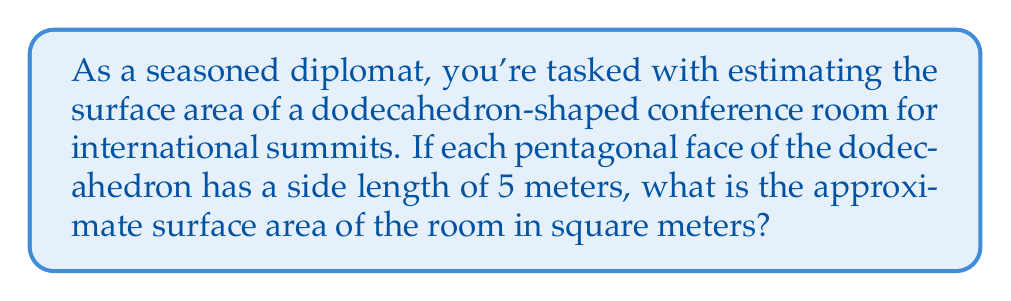Show me your answer to this math problem. Let's approach this step-by-step:

1) A dodecahedron has 12 pentagonal faces.

2) To find the surface area, we need to calculate the area of one pentagonal face and multiply it by 12.

3) The area of a regular pentagon with side length $s$ is given by:

   $$A = \frac{1}{4}\sqrt{25+10\sqrt{5}}s^2$$

4) In this case, $s = 5$ meters. Let's substitute this into the formula:

   $$A = \frac{1}{4}\sqrt{25+10\sqrt{5}}(5^2)$$

5) Simplify:
   $$A = \frac{25}{4}\sqrt{25+10\sqrt{5}}$$

6) Calculate this value (you may use a calculator):
   $$A \approx 43.01 \text{ m}^2$$

7) Since there are 12 faces, multiply this result by 12:

   $$\text{Total Surface Area} = 12 \times 43.01 \approx 516.12 \text{ m}^2$$

8) Rounding to the nearest whole number for a reasonable estimate:

   $$\text{Total Surface Area} \approx 516 \text{ m}^2$$

This estimation provides a good approximation for planning purposes in diplomatic settings.
Answer: $516 \text{ m}^2$ 